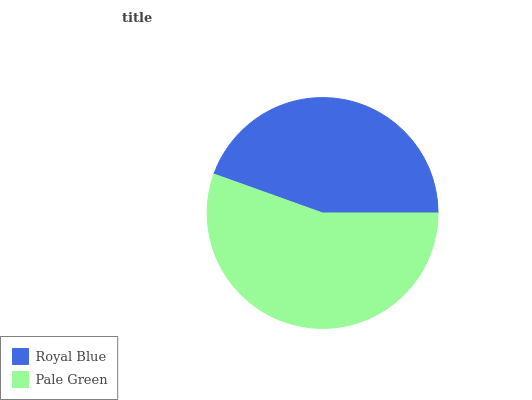Is Royal Blue the minimum?
Answer yes or no. Yes. Is Pale Green the maximum?
Answer yes or no. Yes. Is Pale Green the minimum?
Answer yes or no. No. Is Pale Green greater than Royal Blue?
Answer yes or no. Yes. Is Royal Blue less than Pale Green?
Answer yes or no. Yes. Is Royal Blue greater than Pale Green?
Answer yes or no. No. Is Pale Green less than Royal Blue?
Answer yes or no. No. Is Pale Green the high median?
Answer yes or no. Yes. Is Royal Blue the low median?
Answer yes or no. Yes. Is Royal Blue the high median?
Answer yes or no. No. Is Pale Green the low median?
Answer yes or no. No. 